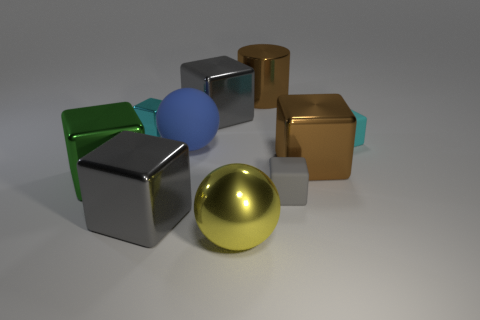Subtract all green spheres. How many gray cubes are left? 3 Subtract 4 blocks. How many blocks are left? 3 Subtract all gray cubes. How many cubes are left? 4 Subtract all tiny matte cubes. How many cubes are left? 5 Subtract all green cubes. Subtract all brown spheres. How many cubes are left? 6 Subtract all spheres. How many objects are left? 8 Subtract all tiny brown metal cubes. Subtract all tiny metal cubes. How many objects are left? 9 Add 4 brown cubes. How many brown cubes are left? 5 Add 6 gray shiny cubes. How many gray shiny cubes exist? 8 Subtract 1 brown cylinders. How many objects are left? 9 